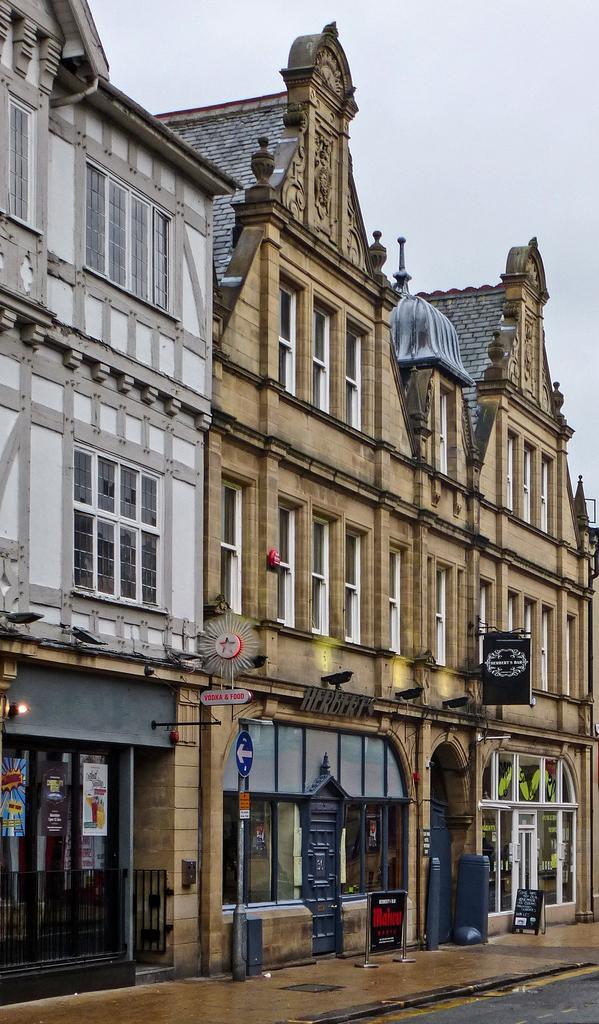Can you describe this image briefly? In this image I can see buildings, sign board, boards attached to the building. I can also see some other objects on the ground. In the background I can see the sky. 